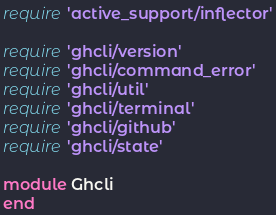<code> <loc_0><loc_0><loc_500><loc_500><_Ruby_>require 'active_support/inflector'

require 'ghcli/version'
require 'ghcli/command_error'
require 'ghcli/util'
require 'ghcli/terminal'
require 'ghcli/github'
require 'ghcli/state'

module Ghcli
end
</code> 